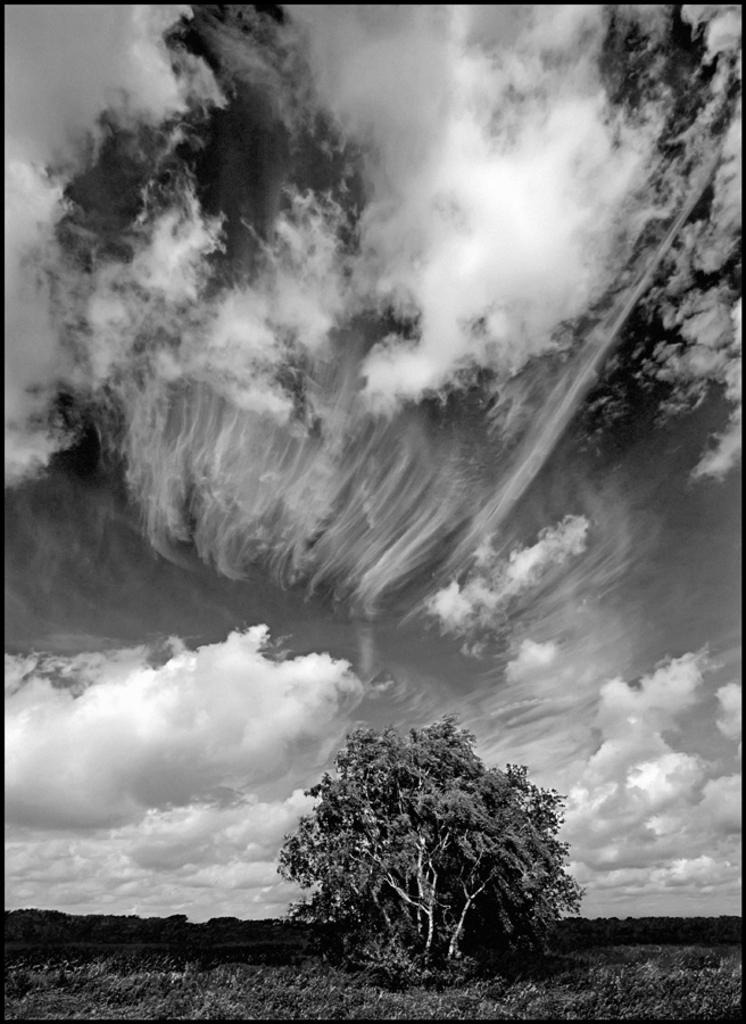What is the color scheme of the image? The image is black and white. What type of vegetation can be seen in the image? There are trees in the image. What covers the ground at the bottom of the image? The ground is covered with grass at the bottom of the image. What is visible in the sky at the top of the image? There are clouds in the sky at the top of the image. What type of meal is being prepared in the image? There is no meal preparation visible in the image; it is a black and white image featuring trees, grass, and clouds. What is the tendency of the clouds in the image? The image does not provide information about the clouds' tendency or movement; it only shows their presence in the sky. 